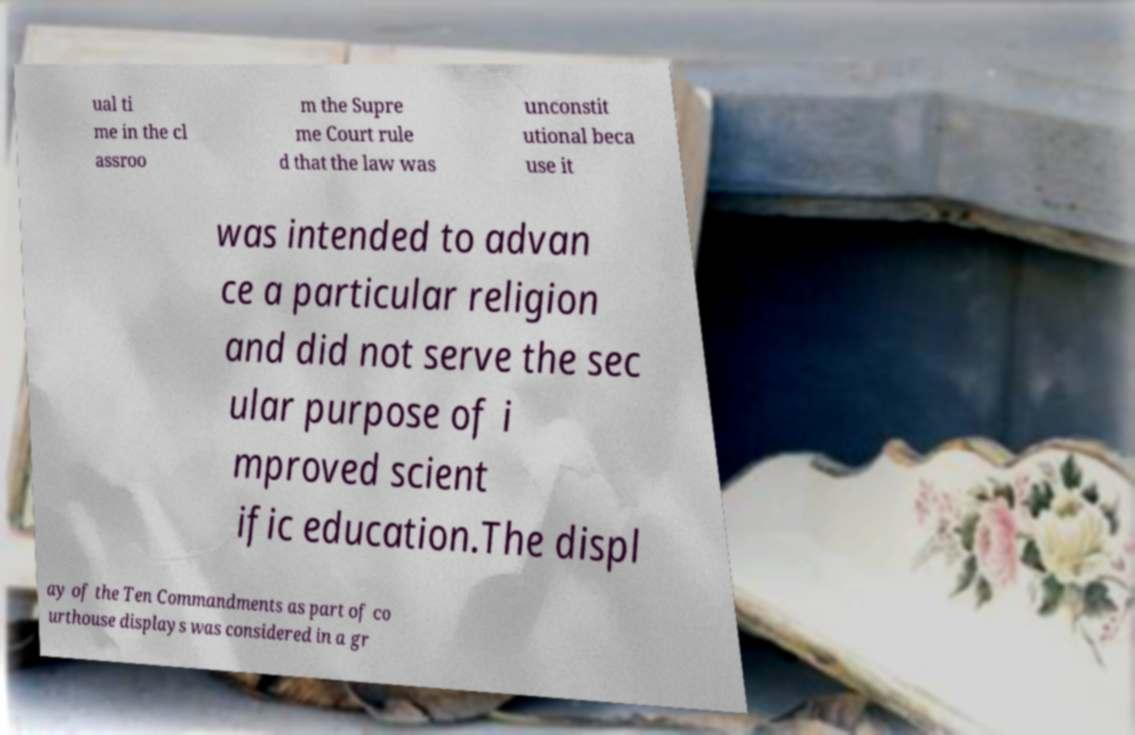For documentation purposes, I need the text within this image transcribed. Could you provide that? ual ti me in the cl assroo m the Supre me Court rule d that the law was unconstit utional beca use it was intended to advan ce a particular religion and did not serve the sec ular purpose of i mproved scient ific education.The displ ay of the Ten Commandments as part of co urthouse displays was considered in a gr 